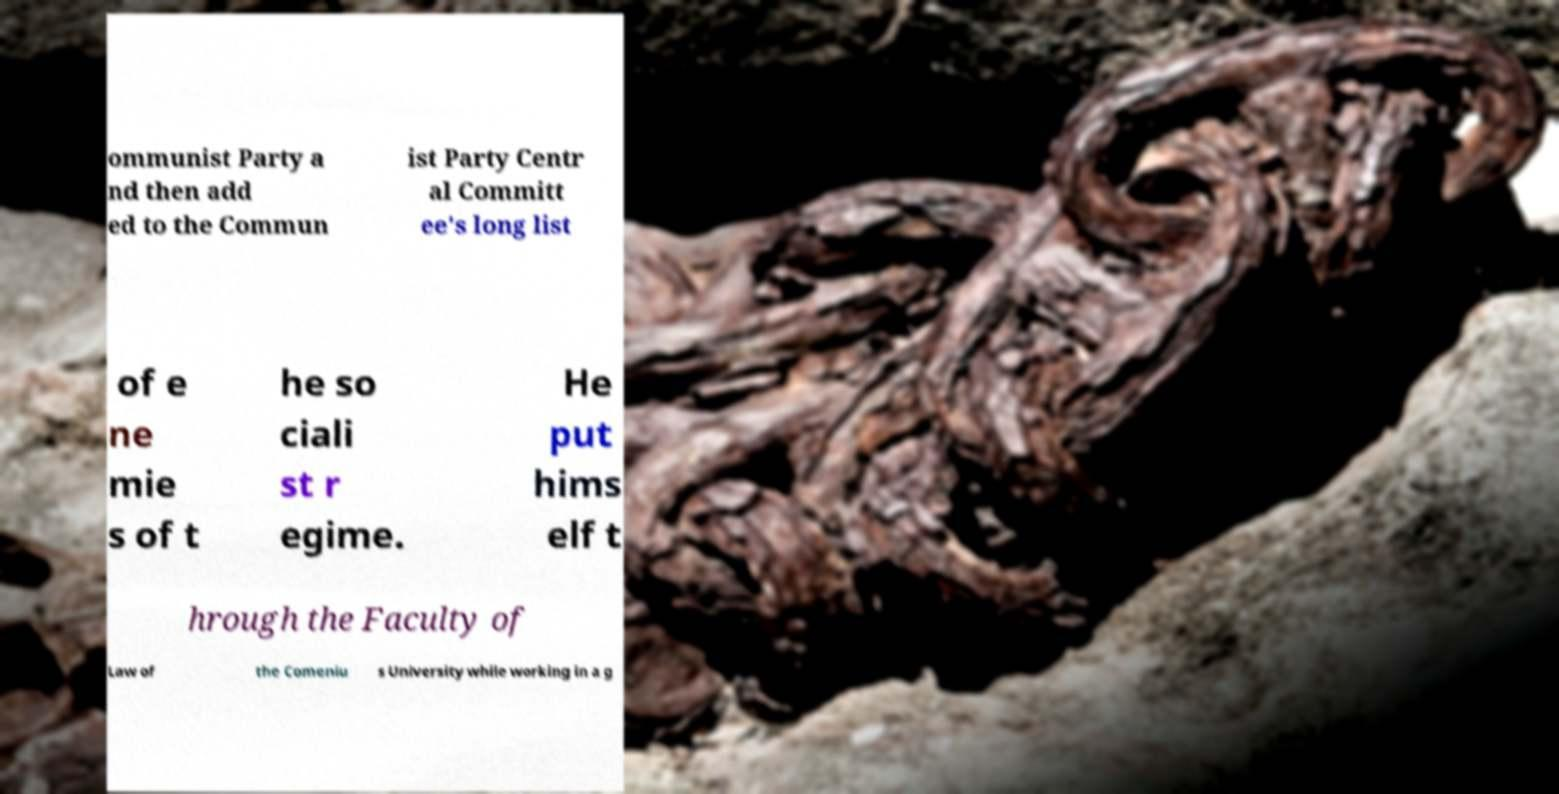I need the written content from this picture converted into text. Can you do that? ommunist Party a nd then add ed to the Commun ist Party Centr al Committ ee's long list of e ne mie s of t he so ciali st r egime. He put hims elf t hrough the Faculty of Law of the Comeniu s University while working in a g 